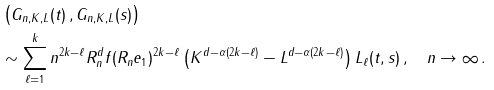<formula> <loc_0><loc_0><loc_500><loc_500>& \left ( G _ { n , K , L } ( t ) \, , G _ { n , K , L } ( s ) \right ) \\ & \sim \sum _ { \ell = 1 } ^ { k } n ^ { 2 k - \ell } R _ { n } ^ { d } f ( R _ { n } e _ { 1 } ) ^ { 2 k - \ell } \left ( K ^ { d - \alpha ( 2 k - \ell ) } - L ^ { d - \alpha ( 2 k - \ell ) } \right ) L _ { \ell } ( t , s ) \, , \quad n \to \infty \, .</formula> 